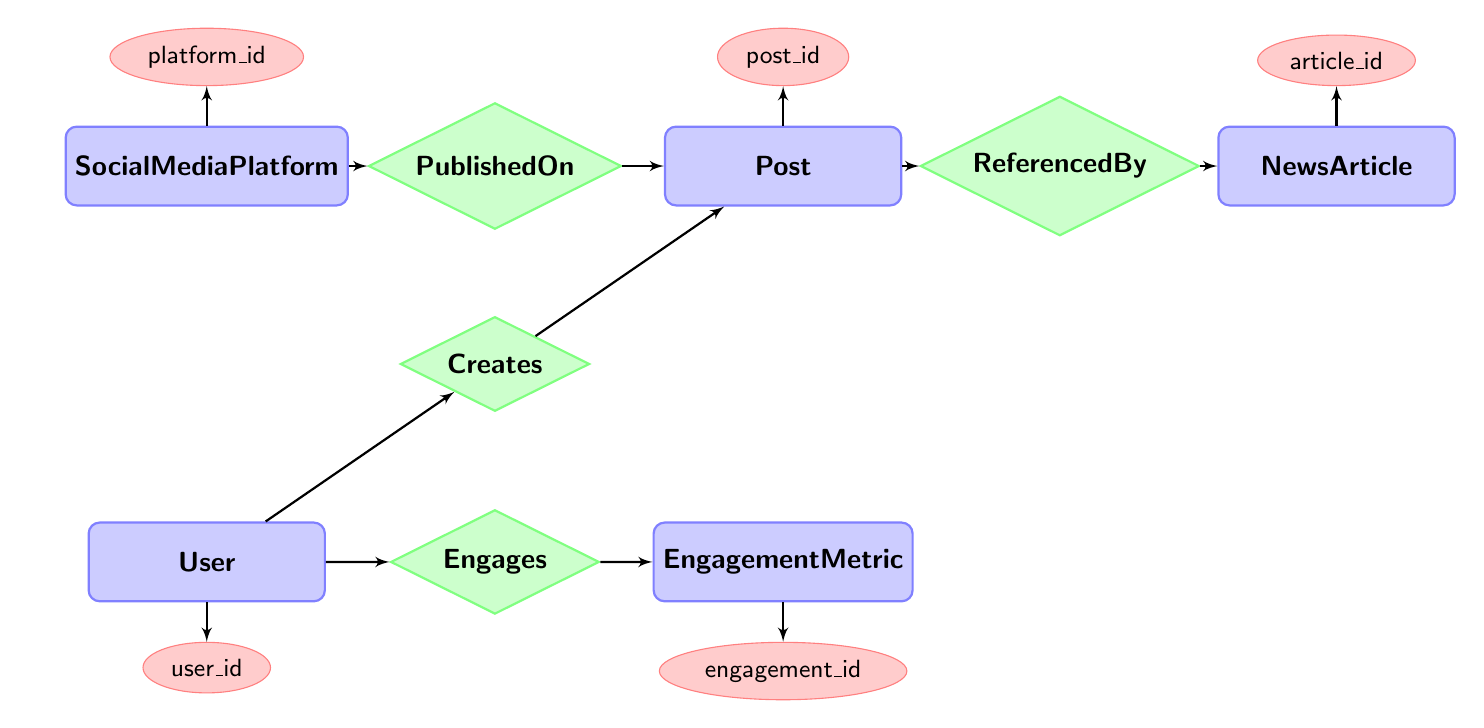What is the primary relationship between User and Post? The primary relationship is "Creates", which signifies that a User is responsible for creating a Post in the system.
Answer: Creates How many attributes are there in the NewsArticle entity? The NewsArticle entity has five attributes: article_id, headline, publication_date, source, and content.
Answer: Five What is the connecting relationship between Post and NewsArticle? The connecting relationship is "ReferencedBy", indicating that a Post can reference one or more NewsArticles.
Answer: ReferencedBy How many entities are present in the diagram? The diagram contains five entities, namely SocialMediaPlatform, Post, NewsArticle, User, and EngagementMetric.
Answer: Five What attribute is linked to the EngagementMetric entity? The engagement_id attribute is linked to the EngagementMetric entity, distinguishing each engagement recorded.
Answer: engagement_id What relationship exists between User and EngagementMetric? The relationship is "Engages", indicating that a User engages with one or more EngagementMetrics.
Answer: Engages What is the purpose of the "PublishedOn" relationship? The "PublishedOn" relationship indicates that a Post is published on a specific SocialMediaPlatform, providing context for the distribution of that Post.
Answer: PublishedOn Which entity can a Post reference? A Post can reference a NewsArticle, which provides additional information or context for the content shared in the Post.
Answer: NewsArticle What is the minimum number of likes, shares, or comments that can be recorded in EngagementMetric? The minimum number recorded for likes, shares, or comments can be zero, as metrics can reflect no engagement.
Answer: Zero 